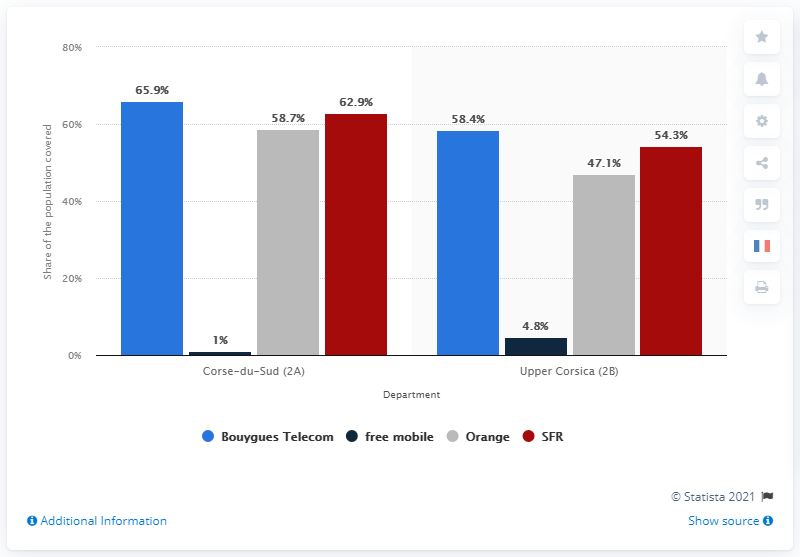Mention a couple of crucial points in this snapshot. Bouygues Telecom provided 4G coverage in Corse-du-Sud. 